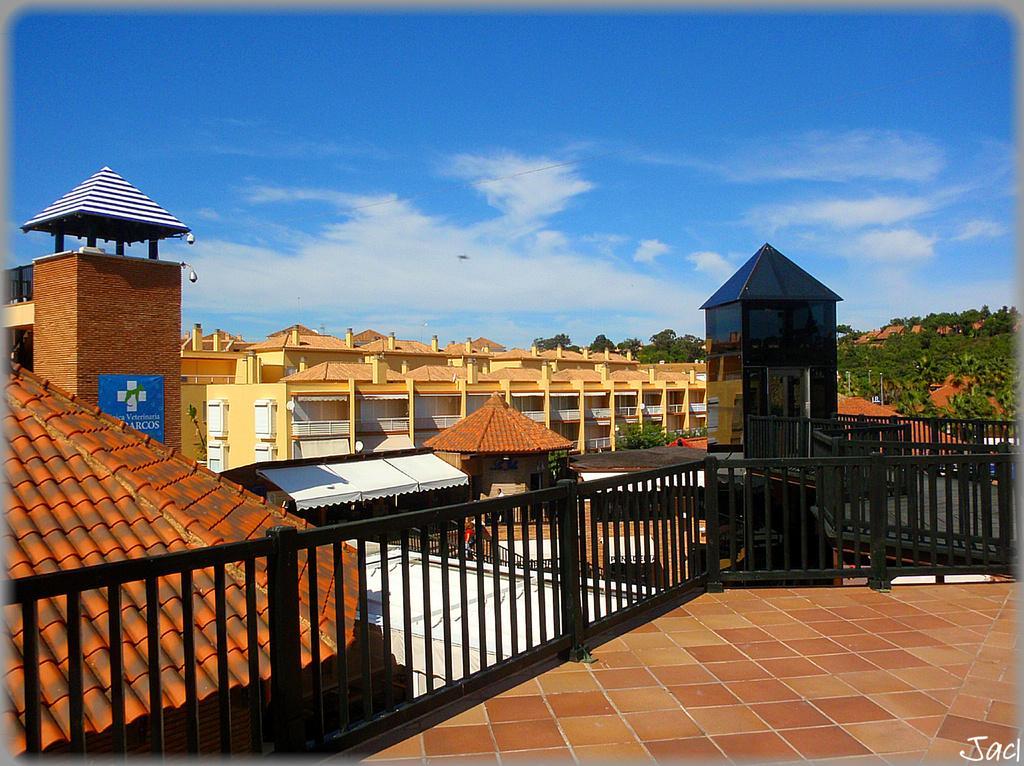In one or two sentences, can you explain what this image depicts? In the foreground I can see a terrace, fence, buildings, trees and mountains. On the top I can see the sky. This image is taken during a day. 